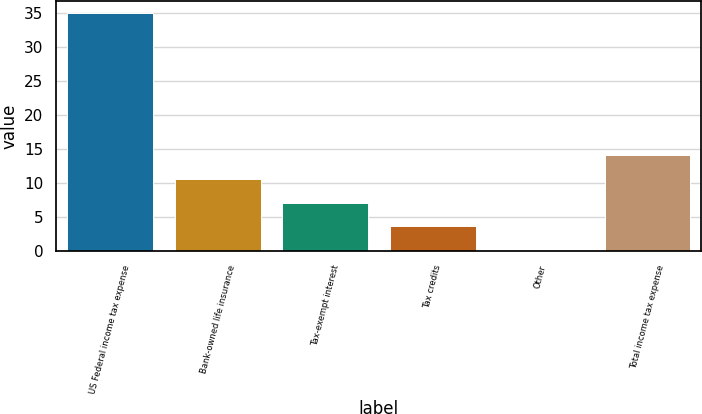Convert chart. <chart><loc_0><loc_0><loc_500><loc_500><bar_chart><fcel>US Federal income tax expense<fcel>Bank-owned life insurance<fcel>Tax-exempt interest<fcel>Tax credits<fcel>Other<fcel>Total income tax expense<nl><fcel>35<fcel>10.57<fcel>7.08<fcel>3.59<fcel>0.1<fcel>14.06<nl></chart> 